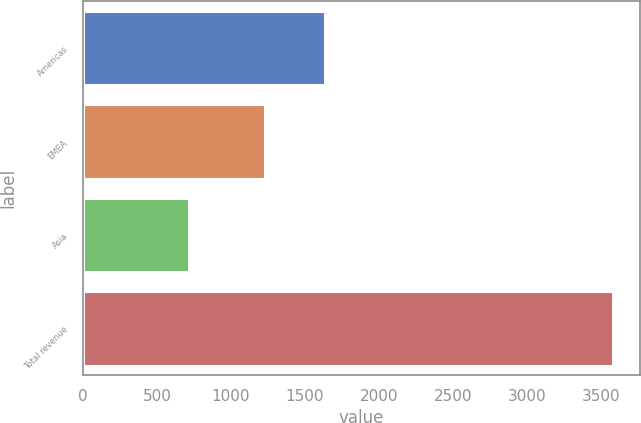Convert chart. <chart><loc_0><loc_0><loc_500><loc_500><bar_chart><fcel>Americas<fcel>EMEA<fcel>Asia<fcel>Total revenue<nl><fcel>1632.8<fcel>1229.2<fcel>717.9<fcel>3579.9<nl></chart> 